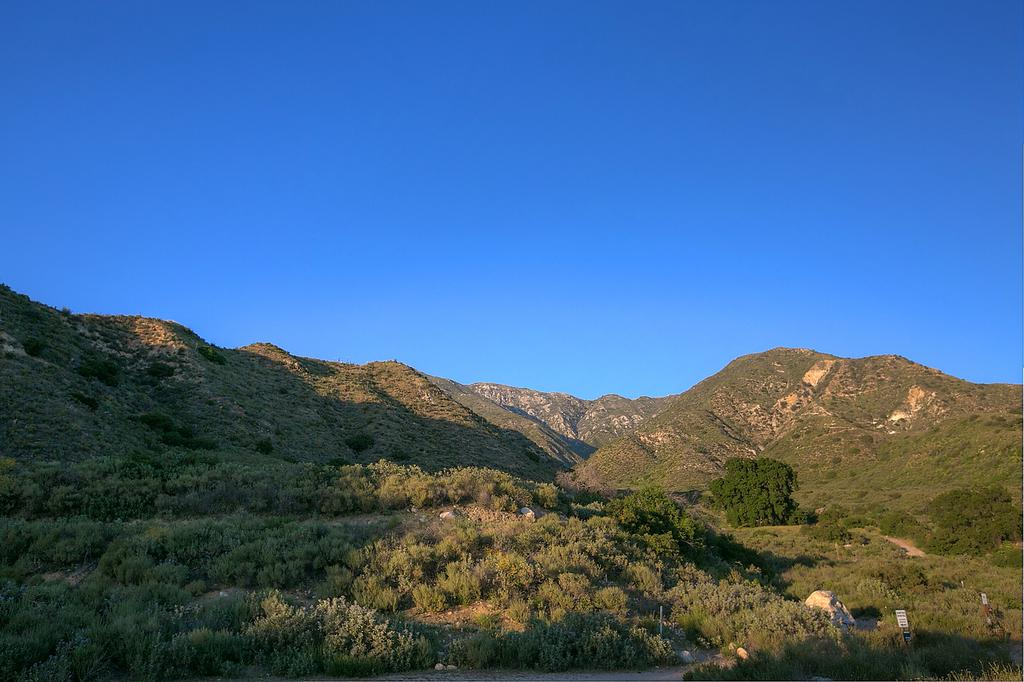What type of natural landscape is depicted in the image? The image features mountains. What other natural elements can be seen in the image? There are trees and plants in the image. Can you describe the board-like object in the image? There is a board-like object in the image, but its specific purpose or function is not clear. What is the rock in the image used for or associated with? The rock in the image is simply a natural element and does not appear to have any specific purpose or association. What color of ink is used to write on the field in the image? There is no field or writing present in the image, so the question about ink color is not applicable. 